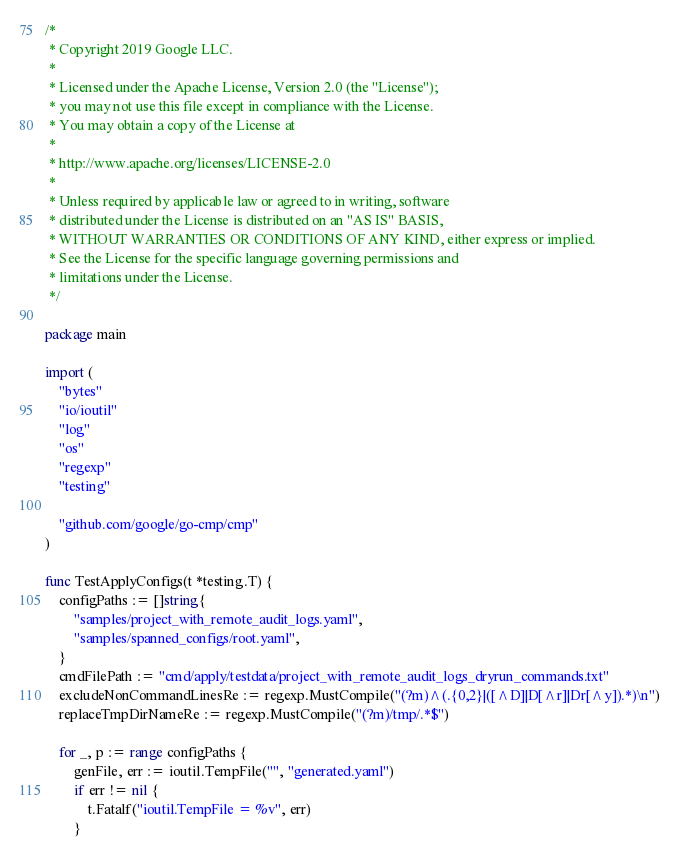Convert code to text. <code><loc_0><loc_0><loc_500><loc_500><_Go_>/*
 * Copyright 2019 Google LLC.
 *
 * Licensed under the Apache License, Version 2.0 (the "License");
 * you may not use this file except in compliance with the License.
 * You may obtain a copy of the License at
 *
 * http://www.apache.org/licenses/LICENSE-2.0
 *
 * Unless required by applicable law or agreed to in writing, software
 * distributed under the License is distributed on an "AS IS" BASIS,
 * WITHOUT WARRANTIES OR CONDITIONS OF ANY KIND, either express or implied.
 * See the License for the specific language governing permissions and
 * limitations under the License.
 */

package main

import (
	"bytes"
	"io/ioutil"
	"log"
	"os"
	"regexp"
	"testing"

	"github.com/google/go-cmp/cmp"
)

func TestApplyConfigs(t *testing.T) {
	configPaths := []string{
		"samples/project_with_remote_audit_logs.yaml",
		"samples/spanned_configs/root.yaml",
	}
	cmdFilePath := "cmd/apply/testdata/project_with_remote_audit_logs_dryrun_commands.txt"
	excludeNonCommandLinesRe := regexp.MustCompile("(?m)^(.{0,2}|([^D]|D[^r]|Dr[^y]).*)\n")
	replaceTmpDirNameRe := regexp.MustCompile("(?m)/tmp/.*$")

	for _, p := range configPaths {
		genFile, err := ioutil.TempFile("", "generated.yaml")
		if err != nil {
			t.Fatalf("ioutil.TempFile = %v", err)
		}</code> 